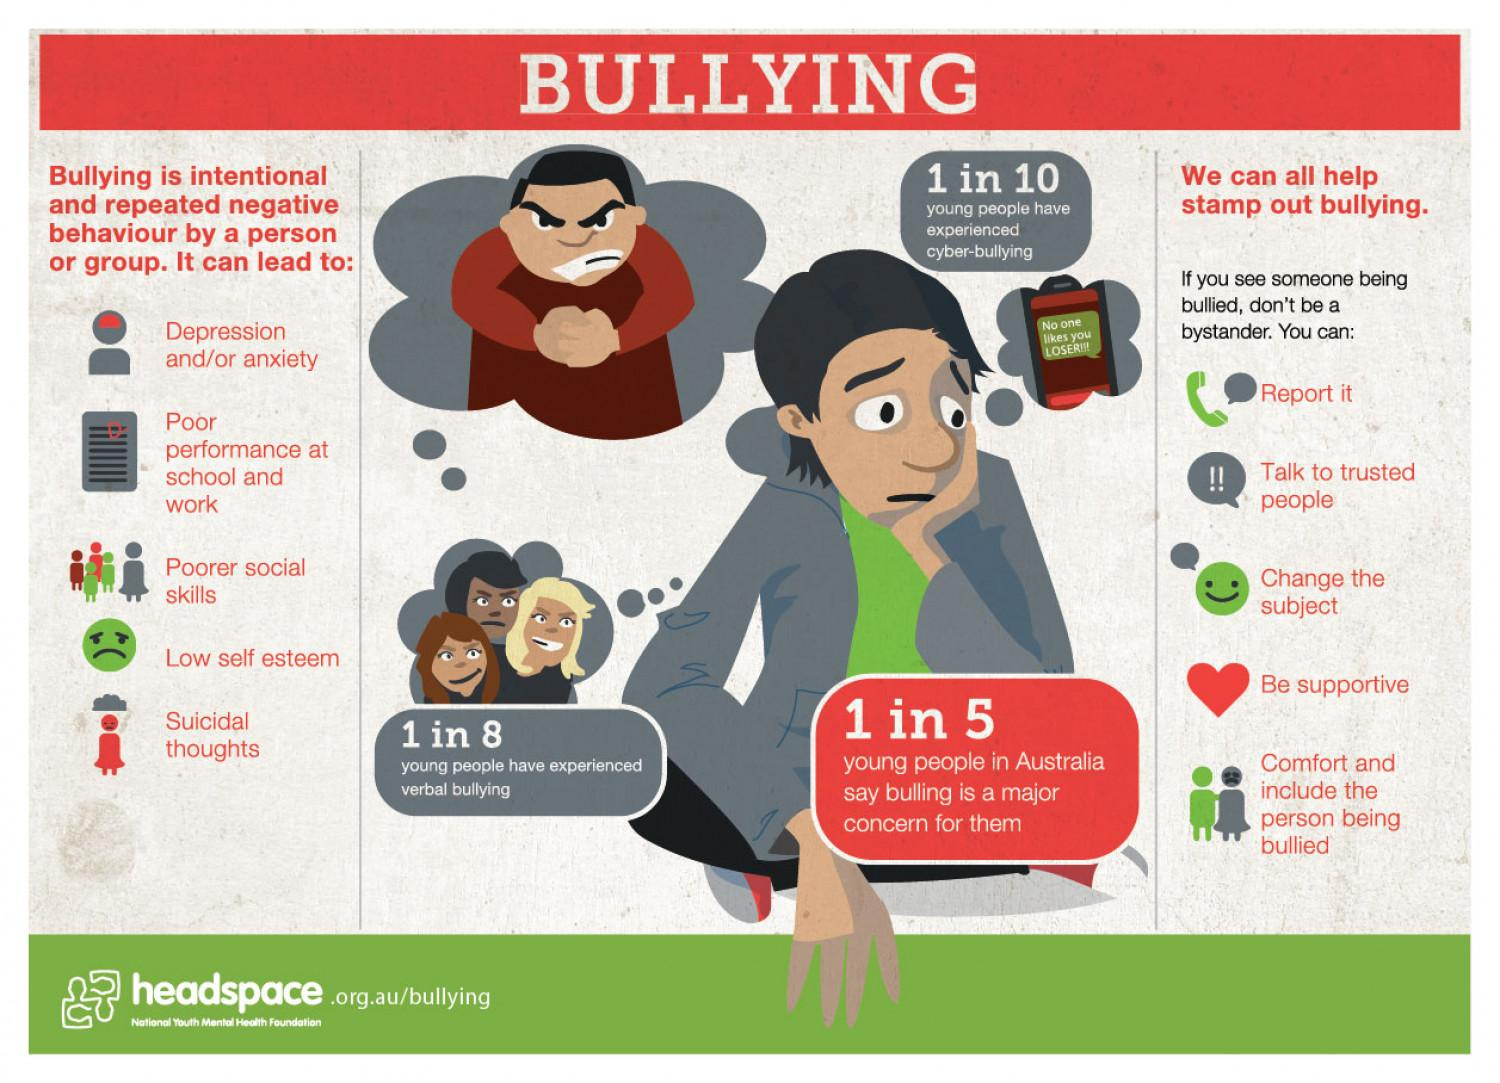Indicate a few pertinent items in this graphic. Verbal bullying affects 1 in 8 young people," according to research. Low self-esteem can be caused by bullying. 